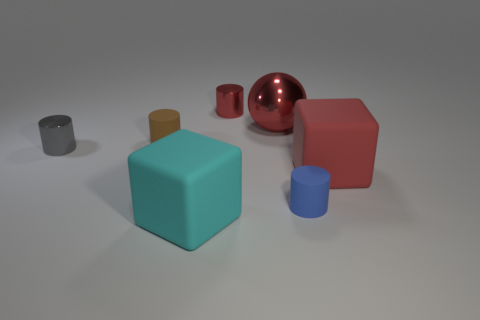Are there the same number of tiny red shiny cylinders that are in front of the blue thing and tiny brown rubber cylinders?
Offer a very short reply. No. There is a large metallic thing; are there any blue matte cylinders right of it?
Make the answer very short. Yes. There is a cyan rubber object that is in front of the small metallic object that is behind the rubber cylinder to the left of the large cyan cube; how big is it?
Ensure brevity in your answer.  Large. Do the big rubber object to the left of the red shiny cylinder and the tiny matte thing behind the blue rubber thing have the same shape?
Provide a short and direct response. No. There is a blue thing that is the same shape as the tiny gray thing; what is its size?
Make the answer very short. Small. How many big red cubes are the same material as the big cyan object?
Your answer should be compact. 1. What material is the tiny gray object?
Offer a terse response. Metal. What is the shape of the red thing behind the large red object that is behind the small gray cylinder?
Your answer should be compact. Cylinder. There is a big thing that is to the left of the small red thing; what is its shape?
Your answer should be very brief. Cube. What number of big things have the same color as the big ball?
Your response must be concise. 1. 